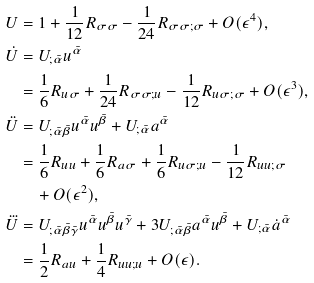Convert formula to latex. <formula><loc_0><loc_0><loc_500><loc_500>U & = 1 + \frac { 1 } { 1 2 } R _ { \sigma \sigma } - \frac { 1 } { 2 4 } R _ { \sigma \sigma ; \sigma } + O ( \epsilon ^ { 4 } ) , \\ \dot { U } & = U _ { ; \bar { \alpha } } u ^ { \bar { \alpha } } \\ & = \frac { 1 } { 6 } R _ { u \sigma } + \frac { 1 } { 2 4 } R _ { \sigma \sigma ; u } - \frac { 1 } { 1 2 } R _ { u \sigma ; \sigma } + O ( \epsilon ^ { 3 } ) , \\ \ddot { U } & = U _ { ; \bar { \alpha } \bar { \beta } } u ^ { \bar { \alpha } } u ^ { \bar { \beta } } + U _ { ; \bar { \alpha } } a ^ { \bar { \alpha } } \\ & = \frac { 1 } { 6 } R _ { u u } + \frac { 1 } { 6 } R _ { a \sigma } + \frac { 1 } { 6 } R _ { u \sigma ; u } - \frac { 1 } { 1 2 } R _ { u u ; \sigma } \\ & \quad + O ( \epsilon ^ { 2 } ) , \\ \dddot { U } & = U _ { ; \bar { \alpha } \bar { \beta } \bar { \gamma } } u ^ { \bar { \alpha } } u ^ { \bar { \beta } } u ^ { \bar { \gamma } } + 3 U _ { ; \bar { \alpha } \bar { \beta } } a ^ { \bar { \alpha } } u ^ { \bar { \beta } } + U _ { ; \bar { \alpha } } \dot { a } ^ { \bar { \alpha } } \\ & = \frac { 1 } { 2 } R _ { a u } + \frac { 1 } { 4 } R _ { u u ; u } + O ( \epsilon ) .</formula> 